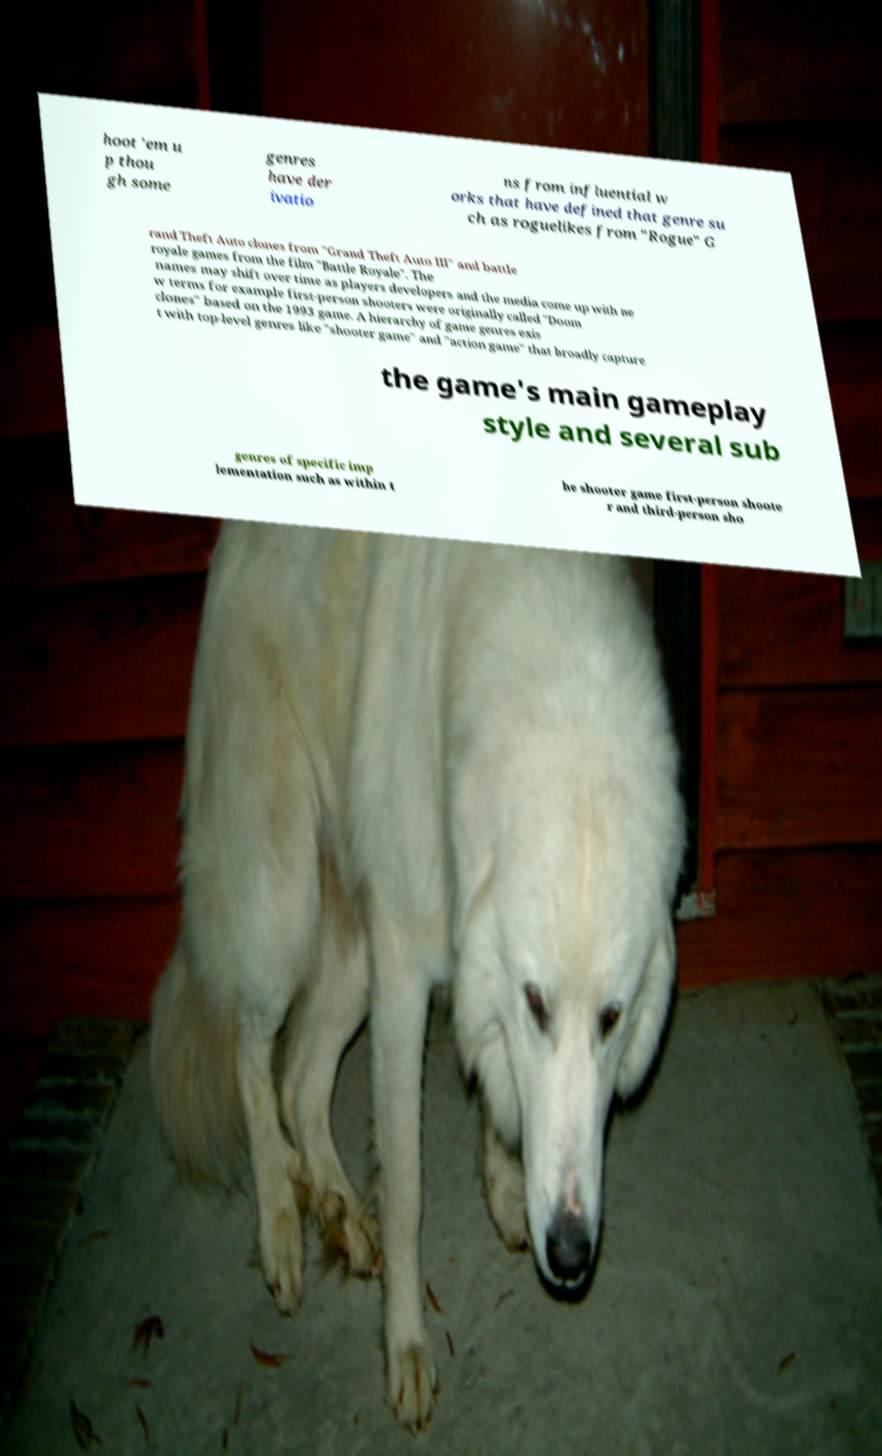Please identify and transcribe the text found in this image. hoot 'em u p thou gh some genres have der ivatio ns from influential w orks that have defined that genre su ch as roguelikes from "Rogue" G rand Theft Auto clones from "Grand Theft Auto III" and battle royale games from the film "Battle Royale". The names may shift over time as players developers and the media come up with ne w terms for example first-person shooters were originally called "Doom clones" based on the 1993 game. A hierarchy of game genres exis t with top-level genres like "shooter game" and "action game" that broadly capture the game's main gameplay style and several sub genres of specific imp lementation such as within t he shooter game first-person shoote r and third-person sho 